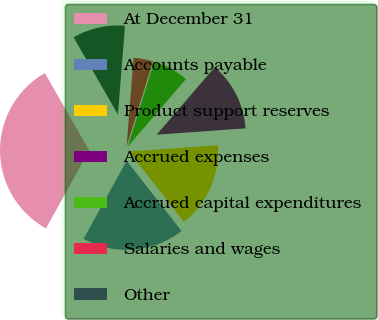Convert chart to OTSL. <chart><loc_0><loc_0><loc_500><loc_500><pie_chart><fcel>At December 31<fcel>Accounts payable<fcel>Product support reserves<fcel>Accrued expenses<fcel>Accrued capital expenditures<fcel>Salaries and wages<fcel>Other<nl><fcel>33.67%<fcel>18.59%<fcel>15.58%<fcel>12.56%<fcel>6.53%<fcel>3.52%<fcel>9.55%<nl></chart> 